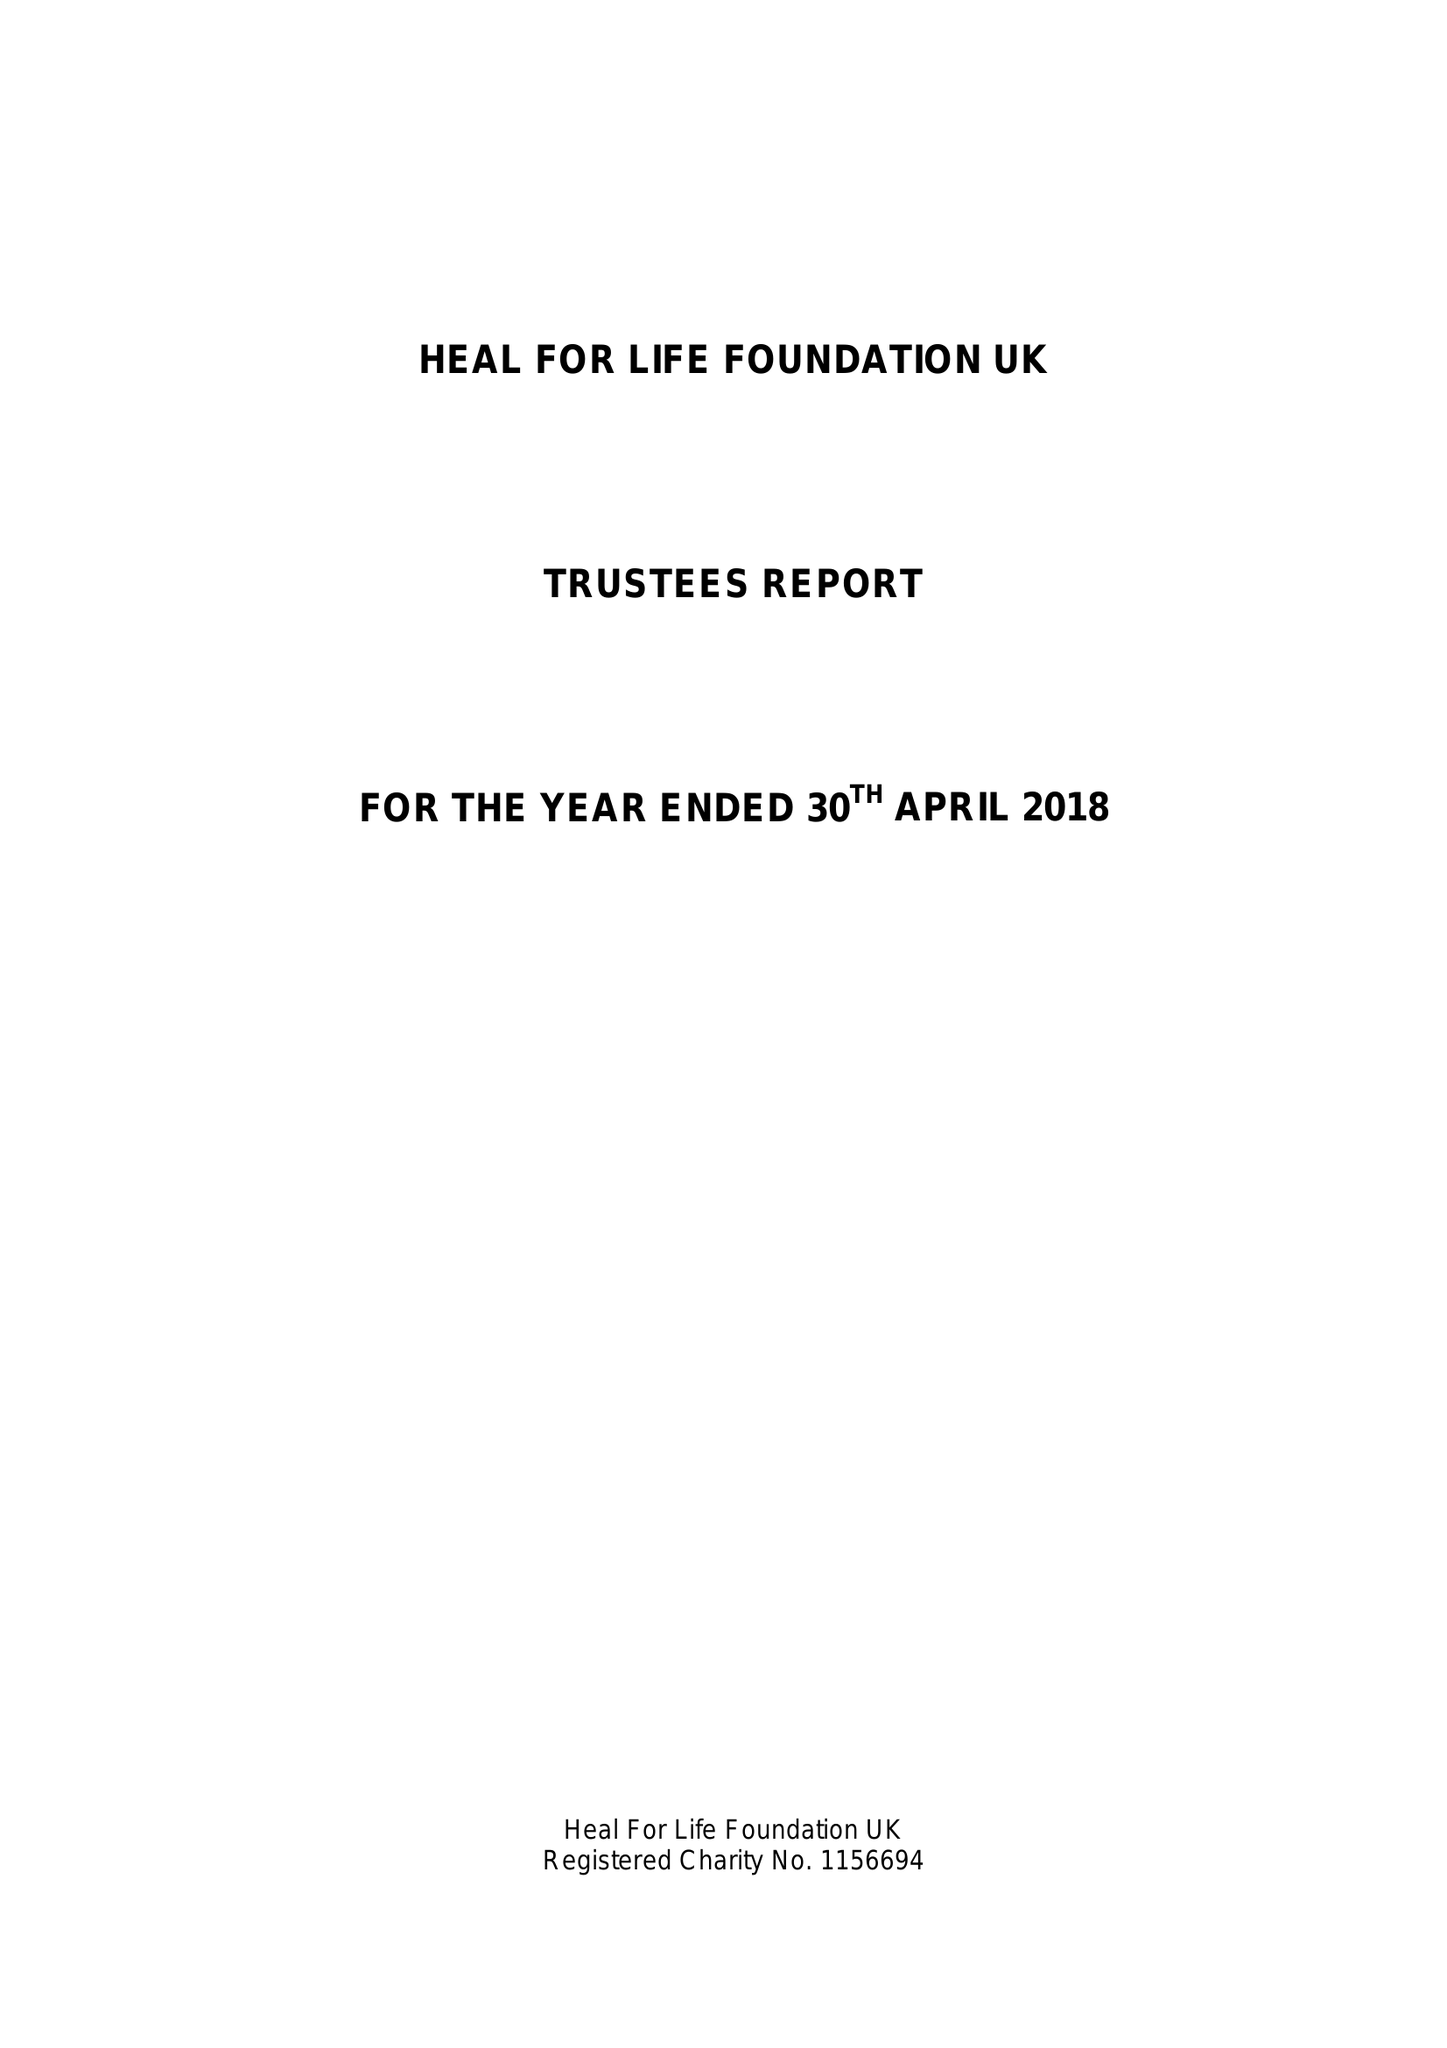What is the value for the charity_number?
Answer the question using a single word or phrase. 1156694 